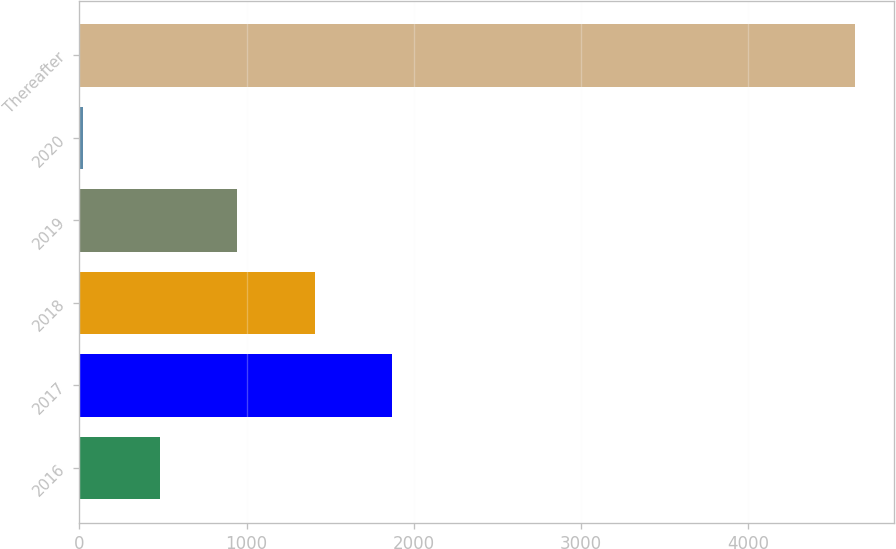Convert chart. <chart><loc_0><loc_0><loc_500><loc_500><bar_chart><fcel>2016<fcel>2017<fcel>2018<fcel>2019<fcel>2020<fcel>Thereafter<nl><fcel>483.5<fcel>1868<fcel>1406.5<fcel>945<fcel>22<fcel>4637<nl></chart> 